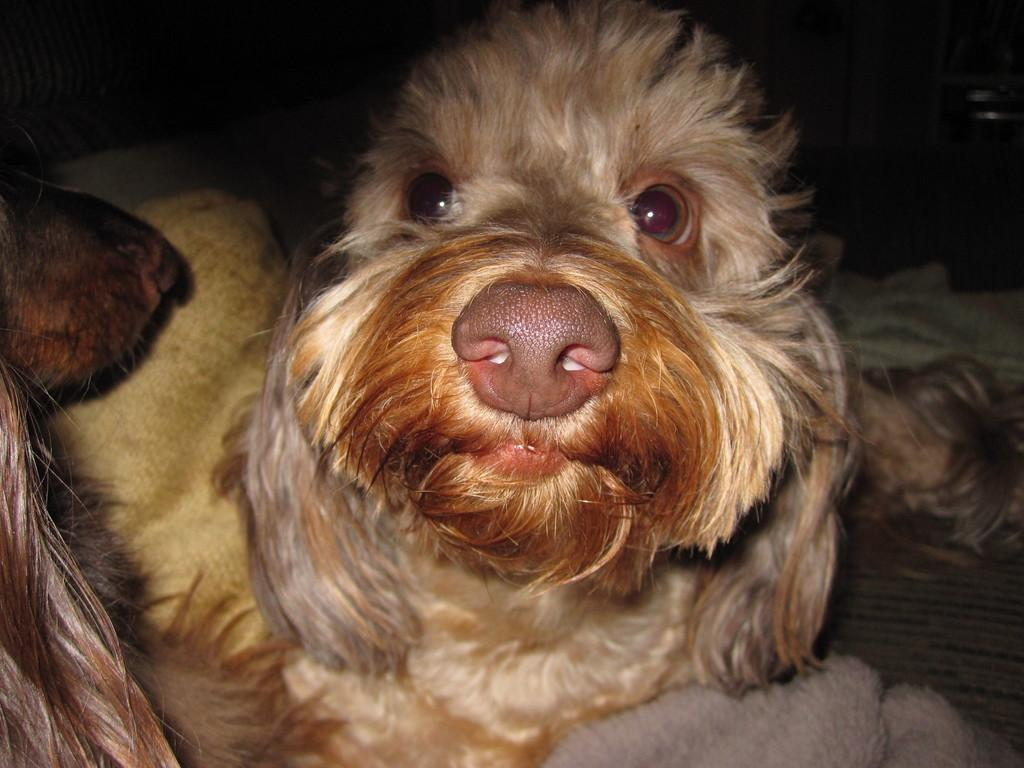How many dogs are in the image? There are two dogs in the image. What can be observed about the background of the image? The background of the image is dark. What object is present at the bottom of the image? There appears to be a towel at the bottom of the image. What type of snails can be seen crawling on the dogs in the image? There are no snails present in the image; it features two dogs and a dark background. What trade is being conducted between the dogs in the image? There is no trade being conducted between the dogs in the image; they are simply present in the scene. 